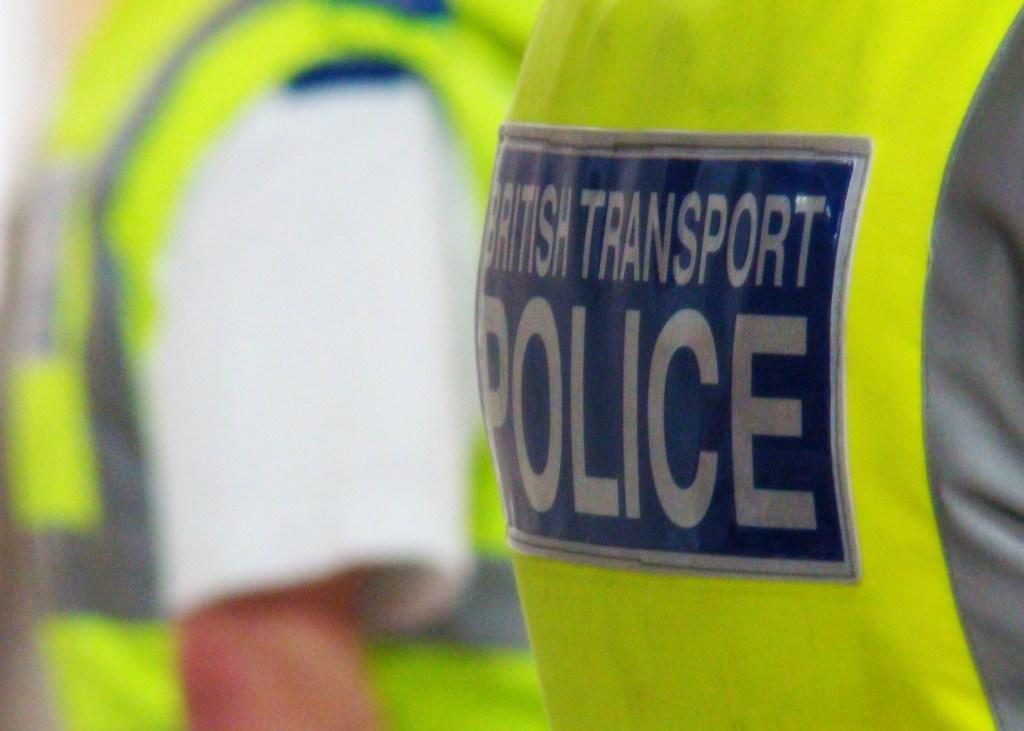<image>
Relay a brief, clear account of the picture shown. Two men wear the yellow vests of the British Transport Police. 